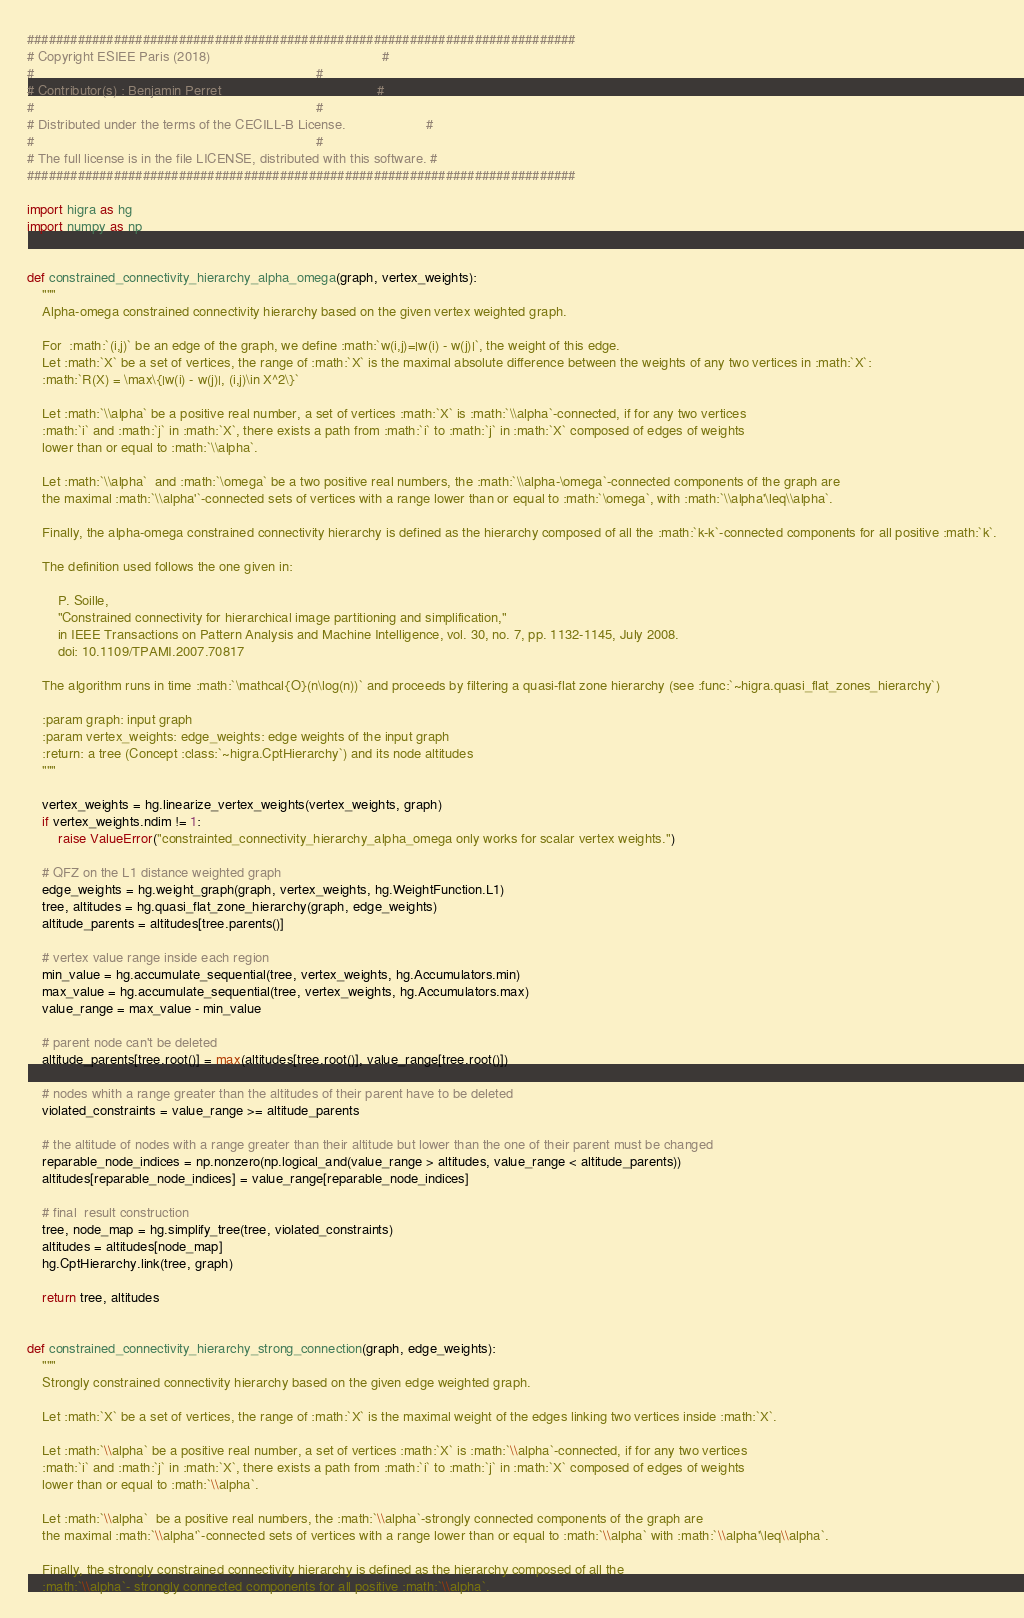Convert code to text. <code><loc_0><loc_0><loc_500><loc_500><_Python_>############################################################################
# Copyright ESIEE Paris (2018)                                             #
#                                                                          #
# Contributor(s) : Benjamin Perret                                         #
#                                                                          #
# Distributed under the terms of the CECILL-B License.                     #
#                                                                          #
# The full license is in the file LICENSE, distributed with this software. #
############################################################################

import higra as hg
import numpy as np


def constrained_connectivity_hierarchy_alpha_omega(graph, vertex_weights):
    """
    Alpha-omega constrained connectivity hierarchy based on the given vertex weighted graph.

    For  :math:`(i,j)` be an edge of the graph, we define :math:`w(i,j)=|w(i) - w(j)|`, the weight of this edge.
    Let :math:`X` be a set of vertices, the range of :math:`X` is the maximal absolute difference between the weights of any two vertices in :math:`X`:
    :math:`R(X) = \max\{|w(i) - w(j)|, (i,j)\in X^2\}`

    Let :math:`\\alpha` be a positive real number, a set of vertices :math:`X` is :math:`\\alpha`-connected, if for any two vertices
    :math:`i` and :math:`j` in :math:`X`, there exists a path from :math:`i` to :math:`j` in :math:`X` composed of edges of weights
    lower than or equal to :math:`\\alpha`.

    Let :math:`\\alpha`  and :math:`\omega` be a two positive real numbers, the :math:`\\alpha-\omega`-connected components of the graph are
    the maximal :math:`\\alpha'`-connected sets of vertices with a range lower than or equal to :math:`\omega`, with :math:`\\alpha'\leq\\alpha`.

    Finally, the alpha-omega constrained connectivity hierarchy is defined as the hierarchy composed of all the :math:`k-k`-connected components for all positive :math:`k`.

    The definition used follows the one given in:

        P. Soille,
        "Constrained connectivity for hierarchical image partitioning and simplification,"
        in IEEE Transactions on Pattern Analysis and Machine Intelligence, vol. 30, no. 7, pp. 1132-1145, July 2008.
        doi: 10.1109/TPAMI.2007.70817

    The algorithm runs in time :math:`\mathcal{O}(n\log(n))` and proceeds by filtering a quasi-flat zone hierarchy (see :func:`~higra.quasi_flat_zones_hierarchy`)

    :param graph: input graph
    :param vertex_weights: edge_weights: edge weights of the input graph
    :return: a tree (Concept :class:`~higra.CptHierarchy`) and its node altitudes
    """

    vertex_weights = hg.linearize_vertex_weights(vertex_weights, graph)
    if vertex_weights.ndim != 1:
        raise ValueError("constrainted_connectivity_hierarchy_alpha_omega only works for scalar vertex weights.")

    # QFZ on the L1 distance weighted graph
    edge_weights = hg.weight_graph(graph, vertex_weights, hg.WeightFunction.L1)
    tree, altitudes = hg.quasi_flat_zone_hierarchy(graph, edge_weights)
    altitude_parents = altitudes[tree.parents()]

    # vertex value range inside each region
    min_value = hg.accumulate_sequential(tree, vertex_weights, hg.Accumulators.min)
    max_value = hg.accumulate_sequential(tree, vertex_weights, hg.Accumulators.max)
    value_range = max_value - min_value

    # parent node can't be deleted
    altitude_parents[tree.root()] = max(altitudes[tree.root()], value_range[tree.root()])

    # nodes whith a range greater than the altitudes of their parent have to be deleted
    violated_constraints = value_range >= altitude_parents

    # the altitude of nodes with a range greater than their altitude but lower than the one of their parent must be changed
    reparable_node_indices = np.nonzero(np.logical_and(value_range > altitudes, value_range < altitude_parents))
    altitudes[reparable_node_indices] = value_range[reparable_node_indices]

    # final  result construction
    tree, node_map = hg.simplify_tree(tree, violated_constraints)
    altitudes = altitudes[node_map]
    hg.CptHierarchy.link(tree, graph)

    return tree, altitudes


def constrained_connectivity_hierarchy_strong_connection(graph, edge_weights):
    """
    Strongly constrained connectivity hierarchy based on the given edge weighted graph.

    Let :math:`X` be a set of vertices, the range of :math:`X` is the maximal weight of the edges linking two vertices inside :math:`X`.

    Let :math:`\\alpha` be a positive real number, a set of vertices :math:`X` is :math:`\\alpha`-connected, if for any two vertices
    :math:`i` and :math:`j` in :math:`X`, there exists a path from :math:`i` to :math:`j` in :math:`X` composed of edges of weights
    lower than or equal to :math:`\\alpha`.

    Let :math:`\\alpha`  be a positive real numbers, the :math:`\\alpha`-strongly connected components of the graph are
    the maximal :math:`\\alpha'`-connected sets of vertices with a range lower than or equal to :math:`\\alpha` with :math:`\\alpha'\leq\\alpha`.

    Finally, the strongly constrained connectivity hierarchy is defined as the hierarchy composed of all the
    :math:`\\alpha`- strongly connected components for all positive :math:`\\alpha`.
</code> 